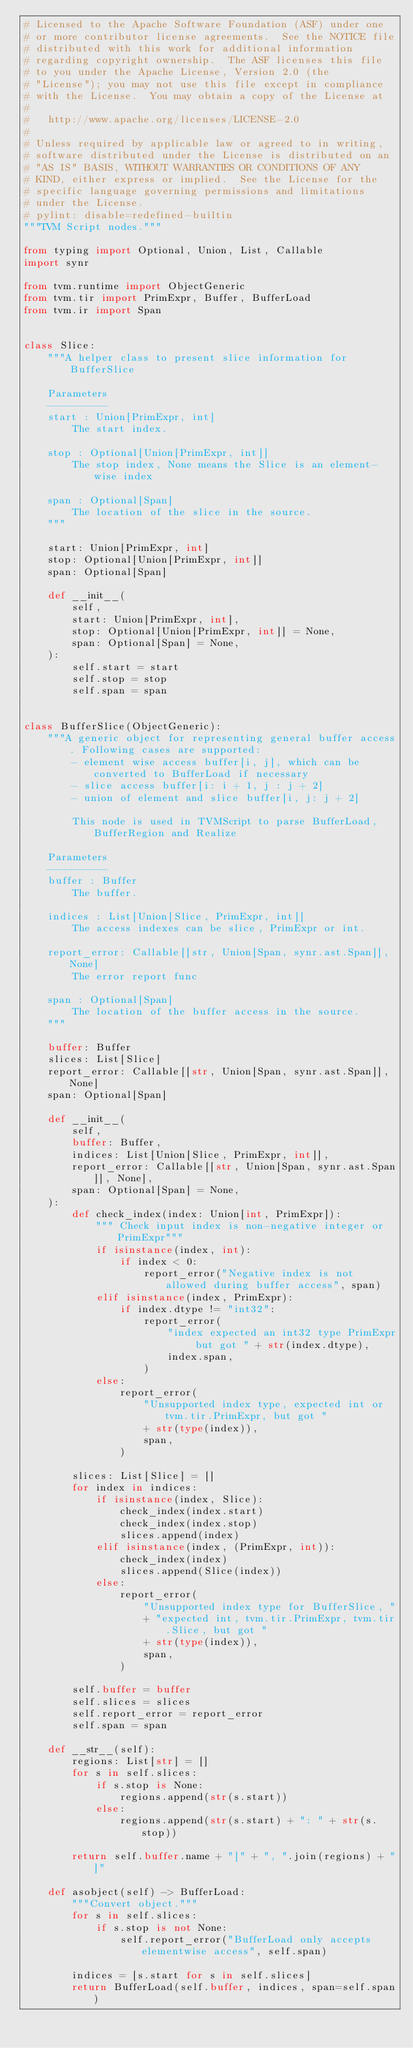<code> <loc_0><loc_0><loc_500><loc_500><_Python_># Licensed to the Apache Software Foundation (ASF) under one
# or more contributor license agreements.  See the NOTICE file
# distributed with this work for additional information
# regarding copyright ownership.  The ASF licenses this file
# to you under the Apache License, Version 2.0 (the
# "License"); you may not use this file except in compliance
# with the License.  You may obtain a copy of the License at
#
#   http://www.apache.org/licenses/LICENSE-2.0
#
# Unless required by applicable law or agreed to in writing,
# software distributed under the License is distributed on an
# "AS IS" BASIS, WITHOUT WARRANTIES OR CONDITIONS OF ANY
# KIND, either express or implied.  See the License for the
# specific language governing permissions and limitations
# under the License.
# pylint: disable=redefined-builtin
"""TVM Script nodes."""

from typing import Optional, Union, List, Callable
import synr

from tvm.runtime import ObjectGeneric
from tvm.tir import PrimExpr, Buffer, BufferLoad
from tvm.ir import Span


class Slice:
    """A helper class to present slice information for BufferSlice

    Parameters
    ----------
    start : Union[PrimExpr, int]
        The start index.

    stop : Optional[Union[PrimExpr, int]]
        The stop index, None means the Slice is an element-wise index

    span : Optional[Span]
        The location of the slice in the source.
    """

    start: Union[PrimExpr, int]
    stop: Optional[Union[PrimExpr, int]]
    span: Optional[Span]

    def __init__(
        self,
        start: Union[PrimExpr, int],
        stop: Optional[Union[PrimExpr, int]] = None,
        span: Optional[Span] = None,
    ):
        self.start = start
        self.stop = stop
        self.span = span


class BufferSlice(ObjectGeneric):
    """A generic object for representing general buffer access. Following cases are supported:
        - element wise access buffer[i, j], which can be converted to BufferLoad if necessary
        - slice access buffer[i: i + 1, j : j + 2]
        - union of element and slice buffer[i, j: j + 2]

        This node is used in TVMScript to parse BufferLoad, BufferRegion and Realize

    Parameters
    ----------
    buffer : Buffer
        The buffer.

    indices : List[Union[Slice, PrimExpr, int]]
        The access indexes can be slice, PrimExpr or int.

    report_error: Callable[[str, Union[Span, synr.ast.Span]], None]
        The error report func

    span : Optional[Span]
        The location of the buffer access in the source.
    """

    buffer: Buffer
    slices: List[Slice]
    report_error: Callable[[str, Union[Span, synr.ast.Span]], None]
    span: Optional[Span]

    def __init__(
        self,
        buffer: Buffer,
        indices: List[Union[Slice, PrimExpr, int]],
        report_error: Callable[[str, Union[Span, synr.ast.Span]], None],
        span: Optional[Span] = None,
    ):
        def check_index(index: Union[int, PrimExpr]):
            """ Check input index is non-negative integer or PrimExpr"""
            if isinstance(index, int):
                if index < 0:
                    report_error("Negative index is not allowed during buffer access", span)
            elif isinstance(index, PrimExpr):
                if index.dtype != "int32":
                    report_error(
                        "index expected an int32 type PrimExpr but got " + str(index.dtype),
                        index.span,
                    )
            else:
                report_error(
                    "Unsupported index type, expected int or tvm.tir.PrimExpr, but got "
                    + str(type(index)),
                    span,
                )

        slices: List[Slice] = []
        for index in indices:
            if isinstance(index, Slice):
                check_index(index.start)
                check_index(index.stop)
                slices.append(index)
            elif isinstance(index, (PrimExpr, int)):
                check_index(index)
                slices.append(Slice(index))
            else:
                report_error(
                    "Unsupported index type for BufferSlice, "
                    + "expected int, tvm.tir.PrimExpr, tvm.tir.Slice, but got "
                    + str(type(index)),
                    span,
                )

        self.buffer = buffer
        self.slices = slices
        self.report_error = report_error
        self.span = span

    def __str__(self):
        regions: List[str] = []
        for s in self.slices:
            if s.stop is None:
                regions.append(str(s.start))
            else:
                regions.append(str(s.start) + ": " + str(s.stop))

        return self.buffer.name + "[" + ", ".join(regions) + "]"

    def asobject(self) -> BufferLoad:
        """Convert object."""
        for s in self.slices:
            if s.stop is not None:
                self.report_error("BufferLoad only accepts elementwise access", self.span)

        indices = [s.start for s in self.slices]
        return BufferLoad(self.buffer, indices, span=self.span)
</code> 